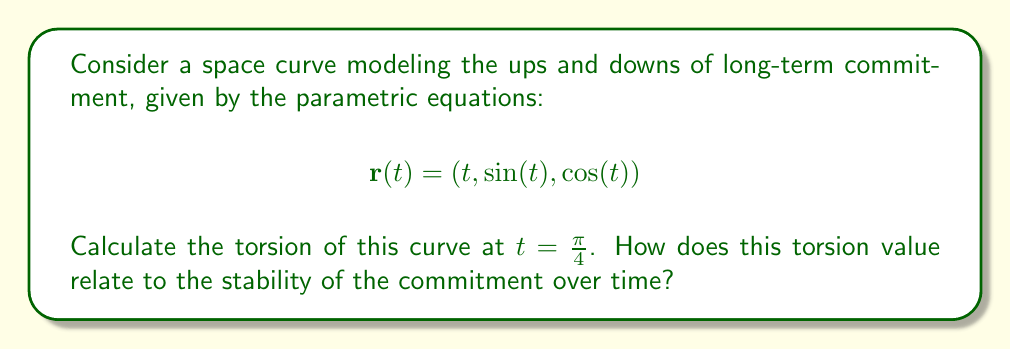Can you solve this math problem? To calculate the torsion of the space curve, we'll follow these steps:

1) First, we need to find $r'(t)$, $r''(t)$, and $r'''(t)$:

   $$r'(t) = (1, \cos(t), -\sin(t))$$
   $$r''(t) = (0, -\sin(t), -\cos(t))$$
   $$r'''(t) = (0, -\cos(t), \sin(t))$$

2) The torsion $\tau$ is given by the formula:

   $$\tau = \frac{[r'(t) \times r''(t)] \cdot r'''(t)}{|r'(t) \times r''(t)|^2}$$

3) Let's calculate $r'(t) \times r''(t)$:

   $$r'(t) \times r''(t) = \begin{vmatrix} 
   i & j & k \\
   1 & \cos(t) & -\sin(t) \\
   0 & -\sin(t) & -\cos(t)
   \end{vmatrix} = (-\cos^2(t) - \sin^2(t), -\sin(t), \cos(t))$$

   $$r'(t) \times r''(t) = (-1, -\sin(t), \cos(t))$$

4) Now, let's calculate $[r'(t) \times r''(t)] \cdot r'''(t)$:

   $$[r'(t) \times r''(t)] \cdot r'''(t) = (-1)(-\cos(t)) + (-\sin(t))(-\cos(t)) + (\cos(t))(\sin(t)) = \cos(t)$$

5) Next, we need to calculate $|r'(t) \times r''(t)|^2$:

   $$|r'(t) \times r''(t)|^2 = (-1)^2 + (-\sin(t))^2 + (\cos(t))^2 = 1 + \sin^2(t) + \cos^2(t) = 2$$

6) Now we can calculate the torsion:

   $$\tau = \frac{\cos(t)}{2}$$

7) At $t = \frac{\pi}{4}$, we have:

   $$\tau(\frac{\pi}{4}) = \frac{\cos(\frac{\pi}{4})}{2} = \frac{\frac{\sqrt{2}}{2}}{2} = \frac{\sqrt{2}}{4}$$

The positive torsion value indicates that the curve is twisting in a right-handed direction. In the context of long-term commitment, this could be interpreted as a tendency for the relationship to strengthen over time, as it moves through various challenges (represented by the ups and downs of the sine and cosine functions).
Answer: $\frac{\sqrt{2}}{4}$ 